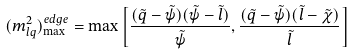Convert formula to latex. <formula><loc_0><loc_0><loc_500><loc_500>( m _ { l q } ^ { 2 } ) ^ { e d g e } _ { \max } = \max \left [ \frac { ( \tilde { q } - \tilde { \psi } ) ( \tilde { \psi } - \tilde { l } ) } { \tilde { \psi } } , \frac { ( \tilde { q } - \tilde { \psi } ) ( \tilde { l } - \tilde { \chi } ) } { \tilde { l } } \right ]</formula> 